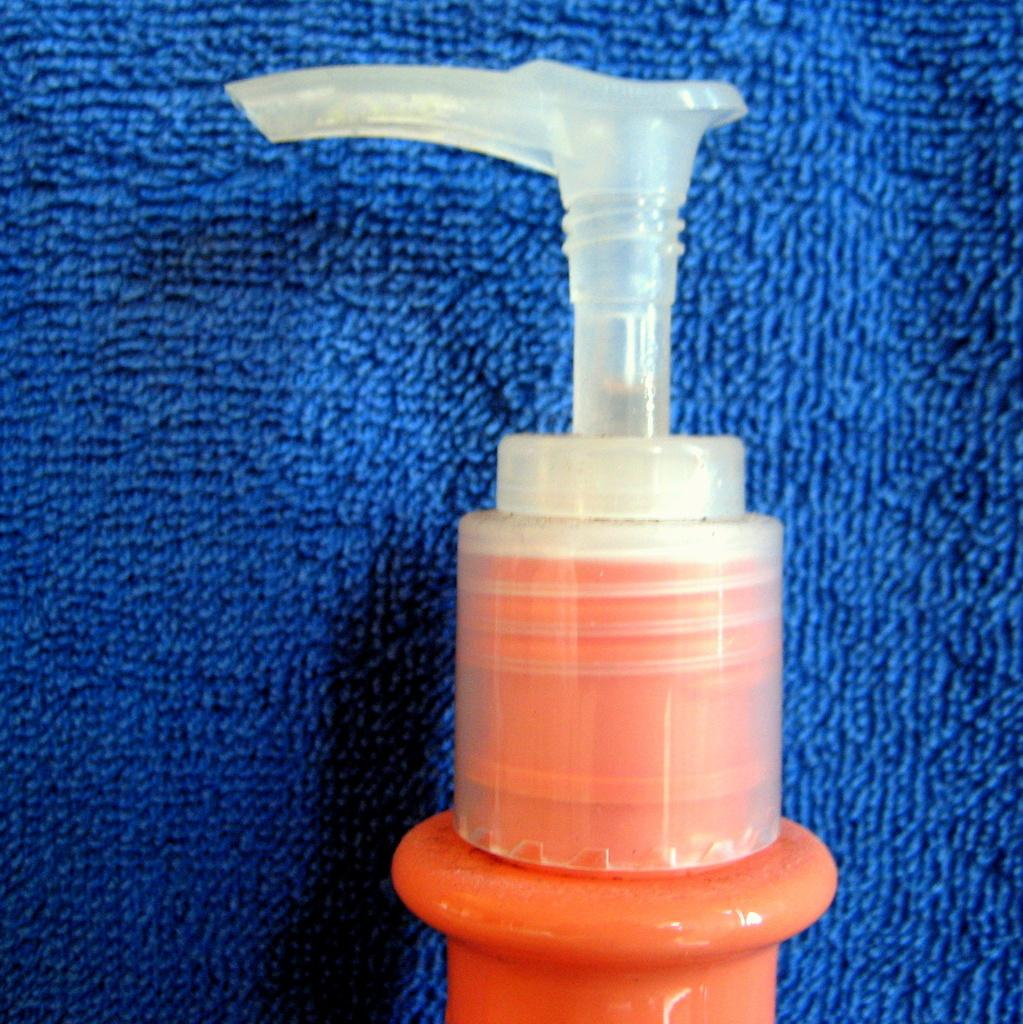What is the main object in the image? There is a sprayer in the image. What material is used for the top part of the sprayer? The top part of the sprayer is made of plastic. Where is the sprayer placed in the image? The sprayer is on a blue cloth-like object. What type of wine is being served in the image? There is no wine present in the image; it features a sprayer on a blue cloth-like object. 